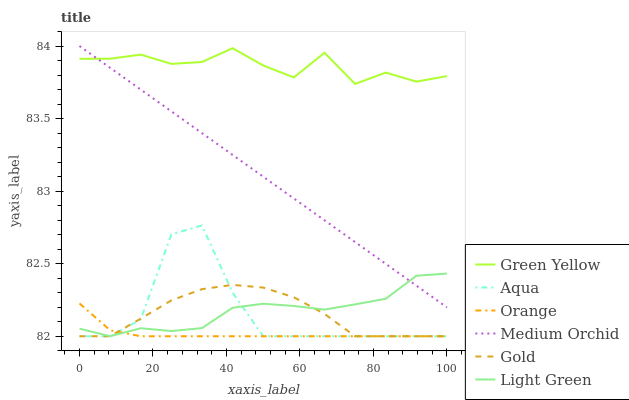Does Orange have the minimum area under the curve?
Answer yes or no. Yes. Does Green Yellow have the maximum area under the curve?
Answer yes or no. Yes. Does Medium Orchid have the minimum area under the curve?
Answer yes or no. No. Does Medium Orchid have the maximum area under the curve?
Answer yes or no. No. Is Medium Orchid the smoothest?
Answer yes or no. Yes. Is Aqua the roughest?
Answer yes or no. Yes. Is Aqua the smoothest?
Answer yes or no. No. Is Medium Orchid the roughest?
Answer yes or no. No. Does Gold have the lowest value?
Answer yes or no. Yes. Does Medium Orchid have the lowest value?
Answer yes or no. No. Does Medium Orchid have the highest value?
Answer yes or no. Yes. Does Aqua have the highest value?
Answer yes or no. No. Is Aqua less than Medium Orchid?
Answer yes or no. Yes. Is Medium Orchid greater than Gold?
Answer yes or no. Yes. Does Aqua intersect Orange?
Answer yes or no. Yes. Is Aqua less than Orange?
Answer yes or no. No. Is Aqua greater than Orange?
Answer yes or no. No. Does Aqua intersect Medium Orchid?
Answer yes or no. No. 